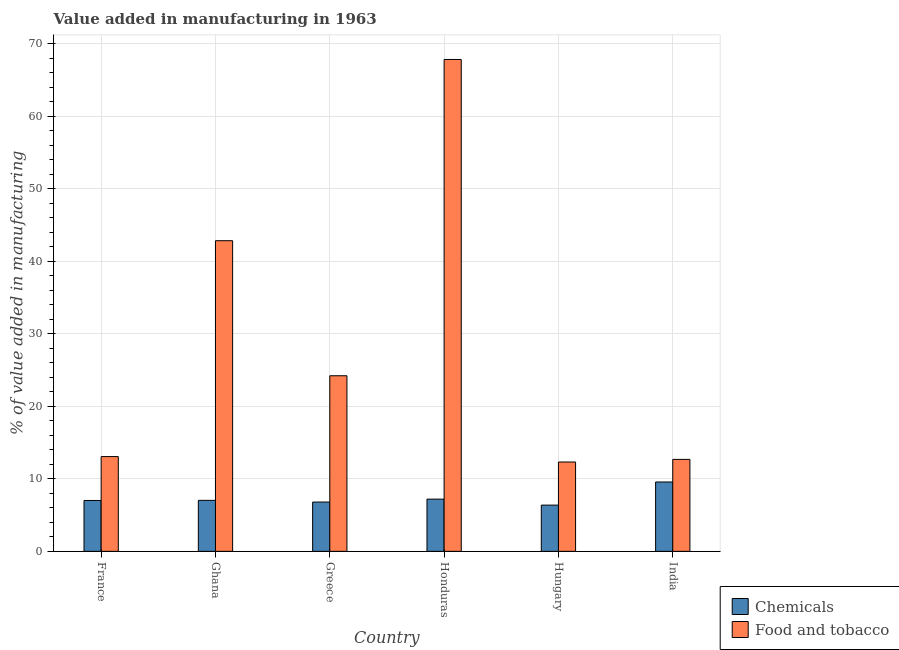How many different coloured bars are there?
Give a very brief answer. 2. In how many cases, is the number of bars for a given country not equal to the number of legend labels?
Provide a succinct answer. 0. What is the value added by manufacturing food and tobacco in Hungary?
Keep it short and to the point. 12.33. Across all countries, what is the maximum value added by manufacturing food and tobacco?
Your answer should be compact. 67.86. Across all countries, what is the minimum value added by  manufacturing chemicals?
Offer a terse response. 6.38. In which country was the value added by manufacturing food and tobacco maximum?
Offer a very short reply. Honduras. In which country was the value added by  manufacturing chemicals minimum?
Keep it short and to the point. Hungary. What is the total value added by  manufacturing chemicals in the graph?
Your response must be concise. 44.01. What is the difference between the value added by manufacturing food and tobacco in Honduras and that in Hungary?
Keep it short and to the point. 55.53. What is the difference between the value added by manufacturing food and tobacco in Ghana and the value added by  manufacturing chemicals in Greece?
Your answer should be compact. 36.05. What is the average value added by  manufacturing chemicals per country?
Keep it short and to the point. 7.34. What is the difference between the value added by  manufacturing chemicals and value added by manufacturing food and tobacco in Greece?
Your response must be concise. -17.42. In how many countries, is the value added by manufacturing food and tobacco greater than 58 %?
Provide a short and direct response. 1. What is the ratio of the value added by manufacturing food and tobacco in France to that in India?
Keep it short and to the point. 1.03. What is the difference between the highest and the second highest value added by  manufacturing chemicals?
Ensure brevity in your answer.  2.36. What is the difference between the highest and the lowest value added by manufacturing food and tobacco?
Provide a succinct answer. 55.53. In how many countries, is the value added by  manufacturing chemicals greater than the average value added by  manufacturing chemicals taken over all countries?
Your answer should be very brief. 1. What does the 1st bar from the left in Ghana represents?
Ensure brevity in your answer.  Chemicals. What does the 1st bar from the right in Ghana represents?
Your answer should be very brief. Food and tobacco. Are all the bars in the graph horizontal?
Provide a succinct answer. No. Does the graph contain any zero values?
Make the answer very short. No. How many legend labels are there?
Offer a terse response. 2. What is the title of the graph?
Ensure brevity in your answer.  Value added in manufacturing in 1963. What is the label or title of the Y-axis?
Your answer should be compact. % of value added in manufacturing. What is the % of value added in manufacturing of Chemicals in France?
Ensure brevity in your answer.  7.02. What is the % of value added in manufacturing in Food and tobacco in France?
Give a very brief answer. 13.07. What is the % of value added in manufacturing in Chemicals in Ghana?
Offer a very short reply. 7.04. What is the % of value added in manufacturing in Food and tobacco in Ghana?
Make the answer very short. 42.86. What is the % of value added in manufacturing in Chemicals in Greece?
Make the answer very short. 6.8. What is the % of value added in manufacturing in Food and tobacco in Greece?
Keep it short and to the point. 24.23. What is the % of value added in manufacturing of Chemicals in Honduras?
Provide a short and direct response. 7.21. What is the % of value added in manufacturing in Food and tobacco in Honduras?
Your response must be concise. 67.86. What is the % of value added in manufacturing of Chemicals in Hungary?
Provide a succinct answer. 6.38. What is the % of value added in manufacturing of Food and tobacco in Hungary?
Give a very brief answer. 12.33. What is the % of value added in manufacturing in Chemicals in India?
Your answer should be compact. 9.57. What is the % of value added in manufacturing in Food and tobacco in India?
Your answer should be compact. 12.69. Across all countries, what is the maximum % of value added in manufacturing in Chemicals?
Provide a short and direct response. 9.57. Across all countries, what is the maximum % of value added in manufacturing in Food and tobacco?
Your response must be concise. 67.86. Across all countries, what is the minimum % of value added in manufacturing in Chemicals?
Ensure brevity in your answer.  6.38. Across all countries, what is the minimum % of value added in manufacturing in Food and tobacco?
Your answer should be compact. 12.33. What is the total % of value added in manufacturing of Chemicals in the graph?
Give a very brief answer. 44.01. What is the total % of value added in manufacturing in Food and tobacco in the graph?
Your response must be concise. 173.03. What is the difference between the % of value added in manufacturing in Chemicals in France and that in Ghana?
Give a very brief answer. -0.02. What is the difference between the % of value added in manufacturing in Food and tobacco in France and that in Ghana?
Give a very brief answer. -29.78. What is the difference between the % of value added in manufacturing of Chemicals in France and that in Greece?
Make the answer very short. 0.22. What is the difference between the % of value added in manufacturing of Food and tobacco in France and that in Greece?
Offer a terse response. -11.15. What is the difference between the % of value added in manufacturing of Chemicals in France and that in Honduras?
Give a very brief answer. -0.19. What is the difference between the % of value added in manufacturing of Food and tobacco in France and that in Honduras?
Your response must be concise. -54.79. What is the difference between the % of value added in manufacturing of Chemicals in France and that in Hungary?
Your answer should be very brief. 0.64. What is the difference between the % of value added in manufacturing of Food and tobacco in France and that in Hungary?
Ensure brevity in your answer.  0.75. What is the difference between the % of value added in manufacturing in Chemicals in France and that in India?
Offer a terse response. -2.55. What is the difference between the % of value added in manufacturing of Food and tobacco in France and that in India?
Your answer should be very brief. 0.39. What is the difference between the % of value added in manufacturing of Chemicals in Ghana and that in Greece?
Your answer should be compact. 0.23. What is the difference between the % of value added in manufacturing in Food and tobacco in Ghana and that in Greece?
Your answer should be very brief. 18.63. What is the difference between the % of value added in manufacturing in Chemicals in Ghana and that in Honduras?
Your response must be concise. -0.17. What is the difference between the % of value added in manufacturing in Food and tobacco in Ghana and that in Honduras?
Your response must be concise. -25. What is the difference between the % of value added in manufacturing of Chemicals in Ghana and that in Hungary?
Your answer should be compact. 0.66. What is the difference between the % of value added in manufacturing of Food and tobacco in Ghana and that in Hungary?
Provide a short and direct response. 30.53. What is the difference between the % of value added in manufacturing in Chemicals in Ghana and that in India?
Your response must be concise. -2.53. What is the difference between the % of value added in manufacturing of Food and tobacco in Ghana and that in India?
Make the answer very short. 30.17. What is the difference between the % of value added in manufacturing in Chemicals in Greece and that in Honduras?
Your answer should be compact. -0.4. What is the difference between the % of value added in manufacturing of Food and tobacco in Greece and that in Honduras?
Your answer should be compact. -43.63. What is the difference between the % of value added in manufacturing in Chemicals in Greece and that in Hungary?
Provide a short and direct response. 0.42. What is the difference between the % of value added in manufacturing in Food and tobacco in Greece and that in Hungary?
Offer a very short reply. 11.9. What is the difference between the % of value added in manufacturing in Chemicals in Greece and that in India?
Provide a succinct answer. -2.77. What is the difference between the % of value added in manufacturing in Food and tobacco in Greece and that in India?
Your answer should be compact. 11.54. What is the difference between the % of value added in manufacturing in Chemicals in Honduras and that in Hungary?
Give a very brief answer. 0.83. What is the difference between the % of value added in manufacturing in Food and tobacco in Honduras and that in Hungary?
Your answer should be compact. 55.53. What is the difference between the % of value added in manufacturing of Chemicals in Honduras and that in India?
Your answer should be compact. -2.36. What is the difference between the % of value added in manufacturing in Food and tobacco in Honduras and that in India?
Provide a short and direct response. 55.17. What is the difference between the % of value added in manufacturing of Chemicals in Hungary and that in India?
Give a very brief answer. -3.19. What is the difference between the % of value added in manufacturing in Food and tobacco in Hungary and that in India?
Provide a short and direct response. -0.36. What is the difference between the % of value added in manufacturing of Chemicals in France and the % of value added in manufacturing of Food and tobacco in Ghana?
Provide a short and direct response. -35.84. What is the difference between the % of value added in manufacturing in Chemicals in France and the % of value added in manufacturing in Food and tobacco in Greece?
Make the answer very short. -17.21. What is the difference between the % of value added in manufacturing of Chemicals in France and the % of value added in manufacturing of Food and tobacco in Honduras?
Provide a short and direct response. -60.84. What is the difference between the % of value added in manufacturing in Chemicals in France and the % of value added in manufacturing in Food and tobacco in Hungary?
Make the answer very short. -5.31. What is the difference between the % of value added in manufacturing in Chemicals in France and the % of value added in manufacturing in Food and tobacco in India?
Your answer should be compact. -5.67. What is the difference between the % of value added in manufacturing of Chemicals in Ghana and the % of value added in manufacturing of Food and tobacco in Greece?
Your answer should be compact. -17.19. What is the difference between the % of value added in manufacturing in Chemicals in Ghana and the % of value added in manufacturing in Food and tobacco in Honduras?
Provide a short and direct response. -60.82. What is the difference between the % of value added in manufacturing in Chemicals in Ghana and the % of value added in manufacturing in Food and tobacco in Hungary?
Your answer should be very brief. -5.29. What is the difference between the % of value added in manufacturing in Chemicals in Ghana and the % of value added in manufacturing in Food and tobacco in India?
Offer a terse response. -5.65. What is the difference between the % of value added in manufacturing of Chemicals in Greece and the % of value added in manufacturing of Food and tobacco in Honduras?
Make the answer very short. -61.06. What is the difference between the % of value added in manufacturing of Chemicals in Greece and the % of value added in manufacturing of Food and tobacco in Hungary?
Your answer should be very brief. -5.53. What is the difference between the % of value added in manufacturing in Chemicals in Greece and the % of value added in manufacturing in Food and tobacco in India?
Keep it short and to the point. -5.89. What is the difference between the % of value added in manufacturing in Chemicals in Honduras and the % of value added in manufacturing in Food and tobacco in Hungary?
Your answer should be very brief. -5.12. What is the difference between the % of value added in manufacturing in Chemicals in Honduras and the % of value added in manufacturing in Food and tobacco in India?
Provide a short and direct response. -5.48. What is the difference between the % of value added in manufacturing in Chemicals in Hungary and the % of value added in manufacturing in Food and tobacco in India?
Your response must be concise. -6.31. What is the average % of value added in manufacturing in Chemicals per country?
Ensure brevity in your answer.  7.34. What is the average % of value added in manufacturing in Food and tobacco per country?
Provide a short and direct response. 28.84. What is the difference between the % of value added in manufacturing of Chemicals and % of value added in manufacturing of Food and tobacco in France?
Your answer should be very brief. -6.06. What is the difference between the % of value added in manufacturing of Chemicals and % of value added in manufacturing of Food and tobacco in Ghana?
Provide a short and direct response. -35.82. What is the difference between the % of value added in manufacturing in Chemicals and % of value added in manufacturing in Food and tobacco in Greece?
Provide a short and direct response. -17.42. What is the difference between the % of value added in manufacturing of Chemicals and % of value added in manufacturing of Food and tobacco in Honduras?
Offer a very short reply. -60.66. What is the difference between the % of value added in manufacturing of Chemicals and % of value added in manufacturing of Food and tobacco in Hungary?
Keep it short and to the point. -5.95. What is the difference between the % of value added in manufacturing in Chemicals and % of value added in manufacturing in Food and tobacco in India?
Provide a succinct answer. -3.12. What is the ratio of the % of value added in manufacturing of Chemicals in France to that in Ghana?
Your answer should be compact. 1. What is the ratio of the % of value added in manufacturing of Food and tobacco in France to that in Ghana?
Your answer should be very brief. 0.31. What is the ratio of the % of value added in manufacturing in Chemicals in France to that in Greece?
Your answer should be very brief. 1.03. What is the ratio of the % of value added in manufacturing in Food and tobacco in France to that in Greece?
Your response must be concise. 0.54. What is the ratio of the % of value added in manufacturing in Chemicals in France to that in Honduras?
Make the answer very short. 0.97. What is the ratio of the % of value added in manufacturing of Food and tobacco in France to that in Honduras?
Make the answer very short. 0.19. What is the ratio of the % of value added in manufacturing in Chemicals in France to that in Hungary?
Offer a terse response. 1.1. What is the ratio of the % of value added in manufacturing of Food and tobacco in France to that in Hungary?
Offer a very short reply. 1.06. What is the ratio of the % of value added in manufacturing of Chemicals in France to that in India?
Provide a short and direct response. 0.73. What is the ratio of the % of value added in manufacturing in Food and tobacco in France to that in India?
Your response must be concise. 1.03. What is the ratio of the % of value added in manufacturing of Chemicals in Ghana to that in Greece?
Your answer should be compact. 1.03. What is the ratio of the % of value added in manufacturing of Food and tobacco in Ghana to that in Greece?
Give a very brief answer. 1.77. What is the ratio of the % of value added in manufacturing of Chemicals in Ghana to that in Honduras?
Ensure brevity in your answer.  0.98. What is the ratio of the % of value added in manufacturing in Food and tobacco in Ghana to that in Honduras?
Make the answer very short. 0.63. What is the ratio of the % of value added in manufacturing in Chemicals in Ghana to that in Hungary?
Keep it short and to the point. 1.1. What is the ratio of the % of value added in manufacturing in Food and tobacco in Ghana to that in Hungary?
Make the answer very short. 3.48. What is the ratio of the % of value added in manufacturing in Chemicals in Ghana to that in India?
Provide a short and direct response. 0.74. What is the ratio of the % of value added in manufacturing of Food and tobacco in Ghana to that in India?
Offer a very short reply. 3.38. What is the ratio of the % of value added in manufacturing in Chemicals in Greece to that in Honduras?
Keep it short and to the point. 0.94. What is the ratio of the % of value added in manufacturing in Food and tobacco in Greece to that in Honduras?
Your answer should be compact. 0.36. What is the ratio of the % of value added in manufacturing of Chemicals in Greece to that in Hungary?
Keep it short and to the point. 1.07. What is the ratio of the % of value added in manufacturing in Food and tobacco in Greece to that in Hungary?
Offer a very short reply. 1.97. What is the ratio of the % of value added in manufacturing of Chemicals in Greece to that in India?
Make the answer very short. 0.71. What is the ratio of the % of value added in manufacturing of Food and tobacco in Greece to that in India?
Ensure brevity in your answer.  1.91. What is the ratio of the % of value added in manufacturing of Chemicals in Honduras to that in Hungary?
Provide a succinct answer. 1.13. What is the ratio of the % of value added in manufacturing in Food and tobacco in Honduras to that in Hungary?
Ensure brevity in your answer.  5.5. What is the ratio of the % of value added in manufacturing in Chemicals in Honduras to that in India?
Give a very brief answer. 0.75. What is the ratio of the % of value added in manufacturing in Food and tobacco in Honduras to that in India?
Provide a succinct answer. 5.35. What is the ratio of the % of value added in manufacturing of Chemicals in Hungary to that in India?
Ensure brevity in your answer.  0.67. What is the ratio of the % of value added in manufacturing of Food and tobacco in Hungary to that in India?
Provide a short and direct response. 0.97. What is the difference between the highest and the second highest % of value added in manufacturing of Chemicals?
Your answer should be compact. 2.36. What is the difference between the highest and the second highest % of value added in manufacturing of Food and tobacco?
Ensure brevity in your answer.  25. What is the difference between the highest and the lowest % of value added in manufacturing in Chemicals?
Your response must be concise. 3.19. What is the difference between the highest and the lowest % of value added in manufacturing in Food and tobacco?
Your answer should be very brief. 55.53. 